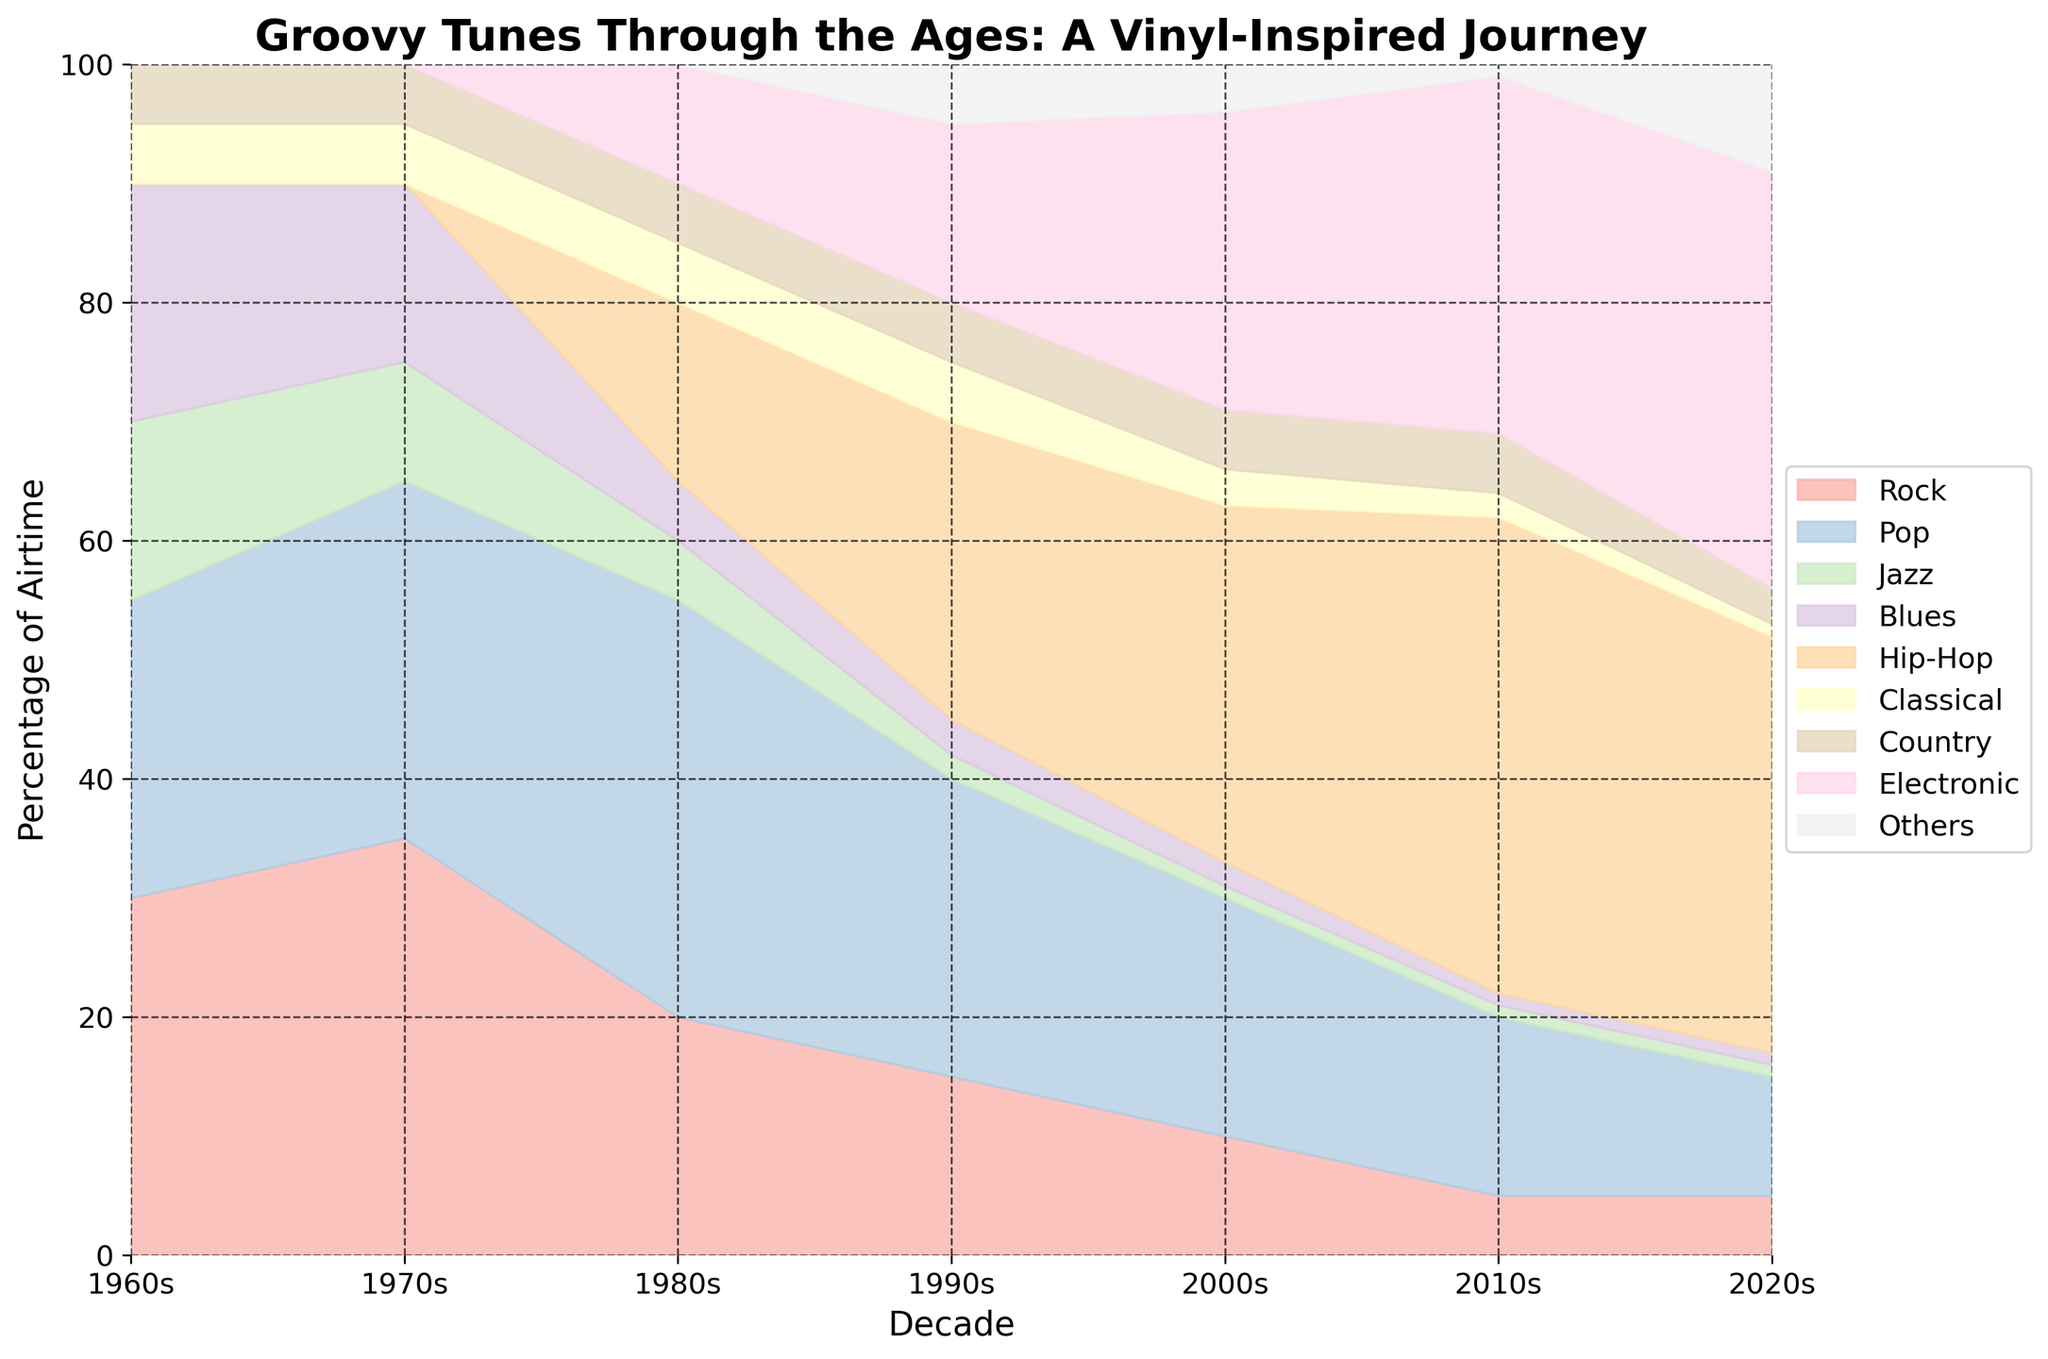Which decade had the highest percentage of airtime dedicated to rock music? The 1970s had the highest percentage of airtime dedicated to rock music at 35%. This can be seen where the rock section reaches its peak on the vertical axis in the 1970s.
Answer: 1970s What's the overall trend of jazz airtime from the 1960s to the 2020s? Jazz airtime shows a decreasing trend from the 1960s to the 2020s, starting at 15% in the 1960s and gradually dropping to 1% in the 2000s and remaining there in the following decades.
Answer: Decreasing By how much did the percentage of airtime for hip-hop increase from the 1980s to the 2010s? In the 1980s, hip-hop had 15% airtime, which increased to 40% in the 2010s. The increase is calculated as 40% - 15% = 25%.
Answer: 25% Which genre saw the highest increase in percentage of airtime from the 1960s to the 2020s? Electronic music saw the highest increase from 0% in the 1960s to 35% in the 2020s. This can be observed from the increasing area covered by electronic music across the decades.
Answer: Electronic In which decade did pop music peak in airtime percentage? Pop music peaked in the 1980s with 35% of the airtime. This peak can be identified by the largest area covered by pop music in that decade.
Answer: 1980s Compare the airtime percentage of classical music in the 1960s and 2020s. In the 1960s, classical music had 5% of the airtime. This dropped to 1% in the 2020s, signifying a 4% decrease.
Answer: Classical music decreased by 4% What is the combined airtime percentage for blues and jazz in the 1970s? In the 1970s, blues had 15% and jazz had 10% of airtime. Combined, this adds up to 15% + 10% = 25%.
Answer: 25% Which decade first introduced hip-hop according to the chart? Hip-hop first appears on the chart in the 1980s with 15% of airtime, marking its introduction.
Answer: 1980s By how much did the airtime for country music change from the 1960s to the 2020s? Country music had 5% airtime in the 1960s and dropped to 3% in the 2020s, indicating a decrease of 2%.
Answer: Decreased by 2% Which genre had the most stable airtime percentage across the decades? Country music remained the most stable with little fluctuation, staying around 5% except in the 2020s where it slightly decreased to 3%.
Answer: Country 